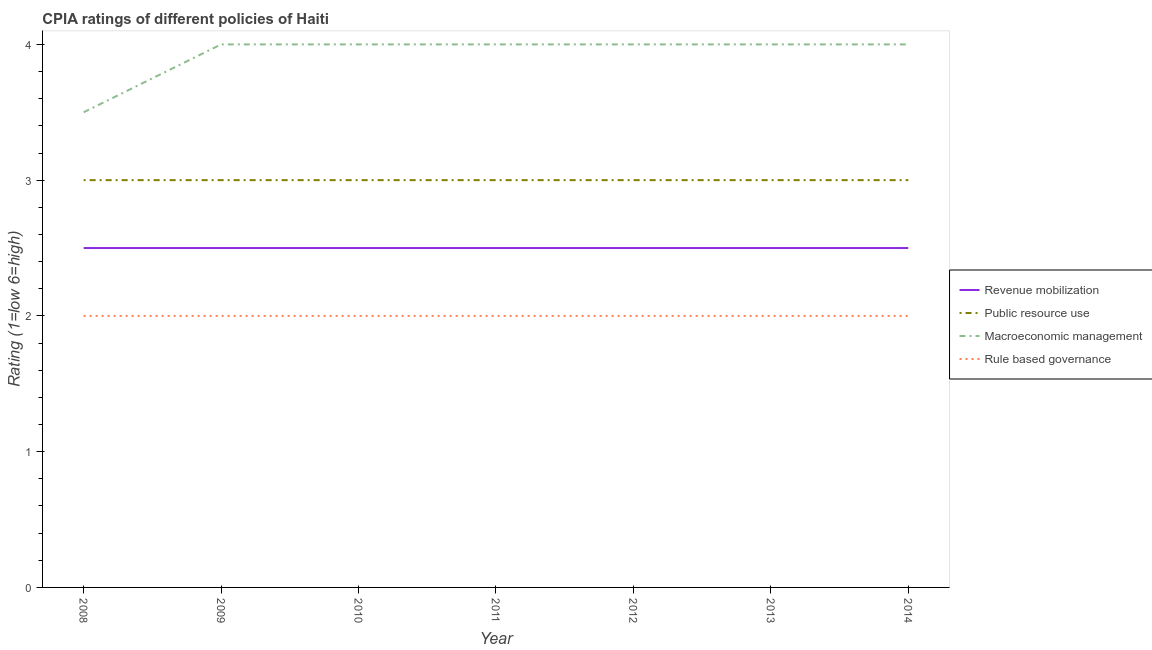How many different coloured lines are there?
Offer a very short reply. 4. Does the line corresponding to cpia rating of public resource use intersect with the line corresponding to cpia rating of rule based governance?
Offer a terse response. No. What is the cpia rating of revenue mobilization in 2011?
Your answer should be compact. 2.5. Across all years, what is the maximum cpia rating of public resource use?
Offer a very short reply. 3. In which year was the cpia rating of rule based governance maximum?
Keep it short and to the point. 2008. What is the total cpia rating of rule based governance in the graph?
Make the answer very short. 14. What is the difference between the cpia rating of revenue mobilization in 2011 and that in 2013?
Provide a short and direct response. 0. What is the average cpia rating of revenue mobilization per year?
Provide a succinct answer. 2.5. In how many years, is the cpia rating of macroeconomic management greater than 2.6?
Offer a very short reply. 7. What is the ratio of the cpia rating of public resource use in 2009 to that in 2014?
Offer a very short reply. 1. Is the cpia rating of macroeconomic management in 2012 less than that in 2013?
Your response must be concise. No. Is the difference between the cpia rating of rule based governance in 2011 and 2012 greater than the difference between the cpia rating of public resource use in 2011 and 2012?
Offer a terse response. No. In how many years, is the cpia rating of macroeconomic management greater than the average cpia rating of macroeconomic management taken over all years?
Offer a very short reply. 6. Is it the case that in every year, the sum of the cpia rating of revenue mobilization and cpia rating of public resource use is greater than the cpia rating of macroeconomic management?
Make the answer very short. Yes. Is the cpia rating of revenue mobilization strictly less than the cpia rating of public resource use over the years?
Provide a short and direct response. Yes. How many lines are there?
Your response must be concise. 4. How many years are there in the graph?
Your answer should be compact. 7. What is the difference between two consecutive major ticks on the Y-axis?
Your answer should be very brief. 1. Are the values on the major ticks of Y-axis written in scientific E-notation?
Keep it short and to the point. No. How many legend labels are there?
Provide a succinct answer. 4. What is the title of the graph?
Provide a short and direct response. CPIA ratings of different policies of Haiti. What is the Rating (1=low 6=high) of Macroeconomic management in 2008?
Offer a terse response. 3.5. What is the Rating (1=low 6=high) in Rule based governance in 2009?
Ensure brevity in your answer.  2. What is the Rating (1=low 6=high) in Revenue mobilization in 2010?
Ensure brevity in your answer.  2.5. What is the Rating (1=low 6=high) in Public resource use in 2010?
Keep it short and to the point. 3. What is the Rating (1=low 6=high) of Revenue mobilization in 2011?
Offer a terse response. 2.5. What is the Rating (1=low 6=high) of Macroeconomic management in 2011?
Keep it short and to the point. 4. What is the Rating (1=low 6=high) of Public resource use in 2012?
Keep it short and to the point. 3. What is the Rating (1=low 6=high) in Macroeconomic management in 2012?
Give a very brief answer. 4. What is the Rating (1=low 6=high) in Rule based governance in 2012?
Provide a short and direct response. 2. What is the Rating (1=low 6=high) in Revenue mobilization in 2013?
Your answer should be very brief. 2.5. What is the Rating (1=low 6=high) in Macroeconomic management in 2014?
Your answer should be compact. 4. Across all years, what is the minimum Rating (1=low 6=high) of Revenue mobilization?
Provide a succinct answer. 2.5. Across all years, what is the minimum Rating (1=low 6=high) of Public resource use?
Offer a terse response. 3. Across all years, what is the minimum Rating (1=low 6=high) in Macroeconomic management?
Make the answer very short. 3.5. What is the total Rating (1=low 6=high) of Revenue mobilization in the graph?
Your answer should be compact. 17.5. What is the total Rating (1=low 6=high) in Public resource use in the graph?
Your response must be concise. 21. What is the difference between the Rating (1=low 6=high) in Revenue mobilization in 2008 and that in 2009?
Ensure brevity in your answer.  0. What is the difference between the Rating (1=low 6=high) of Public resource use in 2008 and that in 2009?
Provide a succinct answer. 0. What is the difference between the Rating (1=low 6=high) in Macroeconomic management in 2008 and that in 2009?
Offer a terse response. -0.5. What is the difference between the Rating (1=low 6=high) in Rule based governance in 2008 and that in 2009?
Offer a very short reply. 0. What is the difference between the Rating (1=low 6=high) of Revenue mobilization in 2008 and that in 2010?
Ensure brevity in your answer.  0. What is the difference between the Rating (1=low 6=high) of Public resource use in 2008 and that in 2010?
Offer a terse response. 0. What is the difference between the Rating (1=low 6=high) in Revenue mobilization in 2008 and that in 2011?
Offer a very short reply. 0. What is the difference between the Rating (1=low 6=high) of Public resource use in 2008 and that in 2011?
Make the answer very short. 0. What is the difference between the Rating (1=low 6=high) in Rule based governance in 2008 and that in 2011?
Offer a very short reply. 0. What is the difference between the Rating (1=low 6=high) of Public resource use in 2008 and that in 2012?
Provide a short and direct response. 0. What is the difference between the Rating (1=low 6=high) of Rule based governance in 2008 and that in 2012?
Provide a succinct answer. 0. What is the difference between the Rating (1=low 6=high) of Rule based governance in 2008 and that in 2013?
Your answer should be compact. 0. What is the difference between the Rating (1=low 6=high) of Revenue mobilization in 2008 and that in 2014?
Your response must be concise. 0. What is the difference between the Rating (1=low 6=high) of Public resource use in 2008 and that in 2014?
Offer a terse response. 0. What is the difference between the Rating (1=low 6=high) of Macroeconomic management in 2008 and that in 2014?
Provide a short and direct response. -0.5. What is the difference between the Rating (1=low 6=high) in Revenue mobilization in 2009 and that in 2010?
Your answer should be compact. 0. What is the difference between the Rating (1=low 6=high) of Macroeconomic management in 2009 and that in 2010?
Keep it short and to the point. 0. What is the difference between the Rating (1=low 6=high) in Rule based governance in 2009 and that in 2010?
Make the answer very short. 0. What is the difference between the Rating (1=low 6=high) of Public resource use in 2009 and that in 2011?
Make the answer very short. 0. What is the difference between the Rating (1=low 6=high) of Macroeconomic management in 2009 and that in 2011?
Ensure brevity in your answer.  0. What is the difference between the Rating (1=low 6=high) in Revenue mobilization in 2009 and that in 2012?
Give a very brief answer. 0. What is the difference between the Rating (1=low 6=high) in Public resource use in 2009 and that in 2012?
Offer a terse response. 0. What is the difference between the Rating (1=low 6=high) of Public resource use in 2009 and that in 2013?
Your answer should be compact. 0. What is the difference between the Rating (1=low 6=high) of Revenue mobilization in 2009 and that in 2014?
Offer a very short reply. 0. What is the difference between the Rating (1=low 6=high) of Public resource use in 2009 and that in 2014?
Your answer should be very brief. 0. What is the difference between the Rating (1=low 6=high) in Rule based governance in 2009 and that in 2014?
Offer a very short reply. 0. What is the difference between the Rating (1=low 6=high) in Revenue mobilization in 2010 and that in 2011?
Your answer should be compact. 0. What is the difference between the Rating (1=low 6=high) of Macroeconomic management in 2010 and that in 2012?
Your answer should be very brief. 0. What is the difference between the Rating (1=low 6=high) in Rule based governance in 2010 and that in 2012?
Ensure brevity in your answer.  0. What is the difference between the Rating (1=low 6=high) in Revenue mobilization in 2010 and that in 2013?
Offer a very short reply. 0. What is the difference between the Rating (1=low 6=high) of Rule based governance in 2010 and that in 2013?
Provide a short and direct response. 0. What is the difference between the Rating (1=low 6=high) of Revenue mobilization in 2010 and that in 2014?
Your response must be concise. 0. What is the difference between the Rating (1=low 6=high) of Macroeconomic management in 2011 and that in 2012?
Provide a succinct answer. 0. What is the difference between the Rating (1=low 6=high) of Macroeconomic management in 2011 and that in 2013?
Offer a terse response. 0. What is the difference between the Rating (1=low 6=high) of Revenue mobilization in 2011 and that in 2014?
Offer a terse response. 0. What is the difference between the Rating (1=low 6=high) of Public resource use in 2011 and that in 2014?
Your answer should be compact. 0. What is the difference between the Rating (1=low 6=high) in Public resource use in 2012 and that in 2013?
Your response must be concise. 0. What is the difference between the Rating (1=low 6=high) of Macroeconomic management in 2012 and that in 2013?
Offer a very short reply. 0. What is the difference between the Rating (1=low 6=high) in Rule based governance in 2012 and that in 2013?
Keep it short and to the point. 0. What is the difference between the Rating (1=low 6=high) in Revenue mobilization in 2012 and that in 2014?
Give a very brief answer. 0. What is the difference between the Rating (1=low 6=high) of Public resource use in 2012 and that in 2014?
Offer a very short reply. 0. What is the difference between the Rating (1=low 6=high) in Macroeconomic management in 2012 and that in 2014?
Your answer should be compact. 0. What is the difference between the Rating (1=low 6=high) of Rule based governance in 2012 and that in 2014?
Ensure brevity in your answer.  0. What is the difference between the Rating (1=low 6=high) of Revenue mobilization in 2013 and that in 2014?
Provide a short and direct response. 0. What is the difference between the Rating (1=low 6=high) in Revenue mobilization in 2008 and the Rating (1=low 6=high) in Public resource use in 2009?
Provide a succinct answer. -0.5. What is the difference between the Rating (1=low 6=high) of Revenue mobilization in 2008 and the Rating (1=low 6=high) of Rule based governance in 2009?
Your answer should be compact. 0.5. What is the difference between the Rating (1=low 6=high) of Revenue mobilization in 2008 and the Rating (1=low 6=high) of Macroeconomic management in 2010?
Your answer should be compact. -1.5. What is the difference between the Rating (1=low 6=high) in Public resource use in 2008 and the Rating (1=low 6=high) in Macroeconomic management in 2010?
Ensure brevity in your answer.  -1. What is the difference between the Rating (1=low 6=high) of Public resource use in 2008 and the Rating (1=low 6=high) of Rule based governance in 2010?
Your response must be concise. 1. What is the difference between the Rating (1=low 6=high) in Revenue mobilization in 2008 and the Rating (1=low 6=high) in Public resource use in 2011?
Your answer should be very brief. -0.5. What is the difference between the Rating (1=low 6=high) of Revenue mobilization in 2008 and the Rating (1=low 6=high) of Macroeconomic management in 2011?
Keep it short and to the point. -1.5. What is the difference between the Rating (1=low 6=high) in Revenue mobilization in 2008 and the Rating (1=low 6=high) in Rule based governance in 2011?
Ensure brevity in your answer.  0.5. What is the difference between the Rating (1=low 6=high) in Public resource use in 2008 and the Rating (1=low 6=high) in Macroeconomic management in 2011?
Provide a short and direct response. -1. What is the difference between the Rating (1=low 6=high) of Macroeconomic management in 2008 and the Rating (1=low 6=high) of Rule based governance in 2011?
Ensure brevity in your answer.  1.5. What is the difference between the Rating (1=low 6=high) of Revenue mobilization in 2008 and the Rating (1=low 6=high) of Public resource use in 2012?
Make the answer very short. -0.5. What is the difference between the Rating (1=low 6=high) in Revenue mobilization in 2008 and the Rating (1=low 6=high) in Rule based governance in 2012?
Provide a succinct answer. 0.5. What is the difference between the Rating (1=low 6=high) of Public resource use in 2008 and the Rating (1=low 6=high) of Macroeconomic management in 2012?
Your answer should be compact. -1. What is the difference between the Rating (1=low 6=high) of Public resource use in 2008 and the Rating (1=low 6=high) of Rule based governance in 2012?
Offer a terse response. 1. What is the difference between the Rating (1=low 6=high) in Revenue mobilization in 2008 and the Rating (1=low 6=high) in Rule based governance in 2013?
Provide a short and direct response. 0.5. What is the difference between the Rating (1=low 6=high) in Revenue mobilization in 2008 and the Rating (1=low 6=high) in Macroeconomic management in 2014?
Keep it short and to the point. -1.5. What is the difference between the Rating (1=low 6=high) in Public resource use in 2008 and the Rating (1=low 6=high) in Rule based governance in 2014?
Keep it short and to the point. 1. What is the difference between the Rating (1=low 6=high) of Macroeconomic management in 2008 and the Rating (1=low 6=high) of Rule based governance in 2014?
Your answer should be very brief. 1.5. What is the difference between the Rating (1=low 6=high) of Revenue mobilization in 2009 and the Rating (1=low 6=high) of Macroeconomic management in 2010?
Keep it short and to the point. -1.5. What is the difference between the Rating (1=low 6=high) in Macroeconomic management in 2009 and the Rating (1=low 6=high) in Rule based governance in 2010?
Provide a short and direct response. 2. What is the difference between the Rating (1=low 6=high) of Revenue mobilization in 2009 and the Rating (1=low 6=high) of Public resource use in 2011?
Offer a very short reply. -0.5. What is the difference between the Rating (1=low 6=high) of Revenue mobilization in 2009 and the Rating (1=low 6=high) of Macroeconomic management in 2011?
Provide a succinct answer. -1.5. What is the difference between the Rating (1=low 6=high) in Revenue mobilization in 2009 and the Rating (1=low 6=high) in Rule based governance in 2011?
Make the answer very short. 0.5. What is the difference between the Rating (1=low 6=high) of Public resource use in 2009 and the Rating (1=low 6=high) of Macroeconomic management in 2011?
Your answer should be very brief. -1. What is the difference between the Rating (1=low 6=high) of Public resource use in 2009 and the Rating (1=low 6=high) of Rule based governance in 2011?
Your answer should be very brief. 1. What is the difference between the Rating (1=low 6=high) in Revenue mobilization in 2009 and the Rating (1=low 6=high) in Macroeconomic management in 2012?
Give a very brief answer. -1.5. What is the difference between the Rating (1=low 6=high) in Public resource use in 2009 and the Rating (1=low 6=high) in Macroeconomic management in 2012?
Make the answer very short. -1. What is the difference between the Rating (1=low 6=high) of Revenue mobilization in 2009 and the Rating (1=low 6=high) of Public resource use in 2013?
Provide a short and direct response. -0.5. What is the difference between the Rating (1=low 6=high) of Public resource use in 2009 and the Rating (1=low 6=high) of Macroeconomic management in 2013?
Keep it short and to the point. -1. What is the difference between the Rating (1=low 6=high) in Public resource use in 2009 and the Rating (1=low 6=high) in Rule based governance in 2013?
Offer a terse response. 1. What is the difference between the Rating (1=low 6=high) in Revenue mobilization in 2009 and the Rating (1=low 6=high) in Public resource use in 2014?
Ensure brevity in your answer.  -0.5. What is the difference between the Rating (1=low 6=high) in Revenue mobilization in 2009 and the Rating (1=low 6=high) in Rule based governance in 2014?
Provide a succinct answer. 0.5. What is the difference between the Rating (1=low 6=high) in Public resource use in 2010 and the Rating (1=low 6=high) in Rule based governance in 2011?
Make the answer very short. 1. What is the difference between the Rating (1=low 6=high) of Macroeconomic management in 2010 and the Rating (1=low 6=high) of Rule based governance in 2011?
Offer a very short reply. 2. What is the difference between the Rating (1=low 6=high) in Revenue mobilization in 2010 and the Rating (1=low 6=high) in Public resource use in 2012?
Make the answer very short. -0.5. What is the difference between the Rating (1=low 6=high) in Revenue mobilization in 2010 and the Rating (1=low 6=high) in Macroeconomic management in 2012?
Your response must be concise. -1.5. What is the difference between the Rating (1=low 6=high) of Revenue mobilization in 2010 and the Rating (1=low 6=high) of Rule based governance in 2012?
Keep it short and to the point. 0.5. What is the difference between the Rating (1=low 6=high) of Public resource use in 2010 and the Rating (1=low 6=high) of Macroeconomic management in 2012?
Make the answer very short. -1. What is the difference between the Rating (1=low 6=high) in Public resource use in 2010 and the Rating (1=low 6=high) in Rule based governance in 2012?
Keep it short and to the point. 1. What is the difference between the Rating (1=low 6=high) of Macroeconomic management in 2010 and the Rating (1=low 6=high) of Rule based governance in 2012?
Your answer should be very brief. 2. What is the difference between the Rating (1=low 6=high) of Revenue mobilization in 2010 and the Rating (1=low 6=high) of Public resource use in 2013?
Provide a short and direct response. -0.5. What is the difference between the Rating (1=low 6=high) in Revenue mobilization in 2010 and the Rating (1=low 6=high) in Macroeconomic management in 2013?
Make the answer very short. -1.5. What is the difference between the Rating (1=low 6=high) of Revenue mobilization in 2010 and the Rating (1=low 6=high) of Rule based governance in 2013?
Offer a terse response. 0.5. What is the difference between the Rating (1=low 6=high) of Public resource use in 2010 and the Rating (1=low 6=high) of Rule based governance in 2013?
Keep it short and to the point. 1. What is the difference between the Rating (1=low 6=high) of Macroeconomic management in 2010 and the Rating (1=low 6=high) of Rule based governance in 2013?
Your answer should be compact. 2. What is the difference between the Rating (1=low 6=high) of Revenue mobilization in 2010 and the Rating (1=low 6=high) of Macroeconomic management in 2014?
Ensure brevity in your answer.  -1.5. What is the difference between the Rating (1=low 6=high) of Revenue mobilization in 2010 and the Rating (1=low 6=high) of Rule based governance in 2014?
Provide a short and direct response. 0.5. What is the difference between the Rating (1=low 6=high) of Macroeconomic management in 2010 and the Rating (1=low 6=high) of Rule based governance in 2014?
Offer a very short reply. 2. What is the difference between the Rating (1=low 6=high) of Revenue mobilization in 2011 and the Rating (1=low 6=high) of Public resource use in 2012?
Ensure brevity in your answer.  -0.5. What is the difference between the Rating (1=low 6=high) in Revenue mobilization in 2011 and the Rating (1=low 6=high) in Rule based governance in 2012?
Offer a terse response. 0.5. What is the difference between the Rating (1=low 6=high) of Public resource use in 2011 and the Rating (1=low 6=high) of Macroeconomic management in 2012?
Offer a very short reply. -1. What is the difference between the Rating (1=low 6=high) of Public resource use in 2011 and the Rating (1=low 6=high) of Macroeconomic management in 2013?
Your answer should be compact. -1. What is the difference between the Rating (1=low 6=high) of Macroeconomic management in 2011 and the Rating (1=low 6=high) of Rule based governance in 2013?
Keep it short and to the point. 2. What is the difference between the Rating (1=low 6=high) of Revenue mobilization in 2011 and the Rating (1=low 6=high) of Public resource use in 2014?
Keep it short and to the point. -0.5. What is the difference between the Rating (1=low 6=high) of Revenue mobilization in 2011 and the Rating (1=low 6=high) of Macroeconomic management in 2014?
Ensure brevity in your answer.  -1.5. What is the difference between the Rating (1=low 6=high) in Public resource use in 2012 and the Rating (1=low 6=high) in Macroeconomic management in 2013?
Provide a succinct answer. -1. What is the difference between the Rating (1=low 6=high) in Public resource use in 2012 and the Rating (1=low 6=high) in Rule based governance in 2013?
Provide a short and direct response. 1. What is the difference between the Rating (1=low 6=high) in Macroeconomic management in 2012 and the Rating (1=low 6=high) in Rule based governance in 2013?
Your answer should be very brief. 2. What is the difference between the Rating (1=low 6=high) in Public resource use in 2012 and the Rating (1=low 6=high) in Rule based governance in 2014?
Offer a very short reply. 1. What is the difference between the Rating (1=low 6=high) in Revenue mobilization in 2013 and the Rating (1=low 6=high) in Macroeconomic management in 2014?
Offer a terse response. -1.5. What is the difference between the Rating (1=low 6=high) in Public resource use in 2013 and the Rating (1=low 6=high) in Rule based governance in 2014?
Your answer should be very brief. 1. What is the average Rating (1=low 6=high) in Public resource use per year?
Offer a very short reply. 3. What is the average Rating (1=low 6=high) of Macroeconomic management per year?
Your answer should be compact. 3.93. In the year 2008, what is the difference between the Rating (1=low 6=high) in Revenue mobilization and Rating (1=low 6=high) in Macroeconomic management?
Offer a very short reply. -1. In the year 2008, what is the difference between the Rating (1=low 6=high) of Revenue mobilization and Rating (1=low 6=high) of Rule based governance?
Your answer should be very brief. 0.5. In the year 2008, what is the difference between the Rating (1=low 6=high) in Public resource use and Rating (1=low 6=high) in Macroeconomic management?
Offer a very short reply. -0.5. In the year 2008, what is the difference between the Rating (1=low 6=high) in Public resource use and Rating (1=low 6=high) in Rule based governance?
Provide a short and direct response. 1. In the year 2008, what is the difference between the Rating (1=low 6=high) of Macroeconomic management and Rating (1=low 6=high) of Rule based governance?
Provide a succinct answer. 1.5. In the year 2009, what is the difference between the Rating (1=low 6=high) of Revenue mobilization and Rating (1=low 6=high) of Public resource use?
Your answer should be compact. -0.5. In the year 2010, what is the difference between the Rating (1=low 6=high) in Revenue mobilization and Rating (1=low 6=high) in Public resource use?
Keep it short and to the point. -0.5. In the year 2010, what is the difference between the Rating (1=low 6=high) in Revenue mobilization and Rating (1=low 6=high) in Macroeconomic management?
Your response must be concise. -1.5. In the year 2010, what is the difference between the Rating (1=low 6=high) of Public resource use and Rating (1=low 6=high) of Macroeconomic management?
Your answer should be very brief. -1. In the year 2011, what is the difference between the Rating (1=low 6=high) of Revenue mobilization and Rating (1=low 6=high) of Public resource use?
Make the answer very short. -0.5. In the year 2011, what is the difference between the Rating (1=low 6=high) of Revenue mobilization and Rating (1=low 6=high) of Macroeconomic management?
Make the answer very short. -1.5. In the year 2011, what is the difference between the Rating (1=low 6=high) in Revenue mobilization and Rating (1=low 6=high) in Rule based governance?
Make the answer very short. 0.5. In the year 2011, what is the difference between the Rating (1=low 6=high) in Public resource use and Rating (1=low 6=high) in Macroeconomic management?
Give a very brief answer. -1. In the year 2011, what is the difference between the Rating (1=low 6=high) of Macroeconomic management and Rating (1=low 6=high) of Rule based governance?
Offer a very short reply. 2. In the year 2012, what is the difference between the Rating (1=low 6=high) in Revenue mobilization and Rating (1=low 6=high) in Public resource use?
Give a very brief answer. -0.5. In the year 2012, what is the difference between the Rating (1=low 6=high) of Public resource use and Rating (1=low 6=high) of Macroeconomic management?
Keep it short and to the point. -1. In the year 2012, what is the difference between the Rating (1=low 6=high) in Macroeconomic management and Rating (1=low 6=high) in Rule based governance?
Your response must be concise. 2. In the year 2013, what is the difference between the Rating (1=low 6=high) of Revenue mobilization and Rating (1=low 6=high) of Public resource use?
Make the answer very short. -0.5. In the year 2013, what is the difference between the Rating (1=low 6=high) in Public resource use and Rating (1=low 6=high) in Rule based governance?
Give a very brief answer. 1. In the year 2013, what is the difference between the Rating (1=low 6=high) in Macroeconomic management and Rating (1=low 6=high) in Rule based governance?
Keep it short and to the point. 2. In the year 2014, what is the difference between the Rating (1=low 6=high) in Revenue mobilization and Rating (1=low 6=high) in Public resource use?
Your answer should be compact. -0.5. In the year 2014, what is the difference between the Rating (1=low 6=high) of Revenue mobilization and Rating (1=low 6=high) of Macroeconomic management?
Offer a terse response. -1.5. In the year 2014, what is the difference between the Rating (1=low 6=high) in Public resource use and Rating (1=low 6=high) in Macroeconomic management?
Your answer should be very brief. -1. What is the ratio of the Rating (1=low 6=high) in Public resource use in 2008 to that in 2009?
Offer a terse response. 1. What is the ratio of the Rating (1=low 6=high) in Public resource use in 2008 to that in 2010?
Keep it short and to the point. 1. What is the ratio of the Rating (1=low 6=high) of Macroeconomic management in 2008 to that in 2010?
Your answer should be very brief. 0.88. What is the ratio of the Rating (1=low 6=high) in Public resource use in 2008 to that in 2011?
Provide a short and direct response. 1. What is the ratio of the Rating (1=low 6=high) of Public resource use in 2008 to that in 2012?
Offer a terse response. 1. What is the ratio of the Rating (1=low 6=high) in Macroeconomic management in 2008 to that in 2012?
Provide a short and direct response. 0.88. What is the ratio of the Rating (1=low 6=high) of Rule based governance in 2008 to that in 2012?
Give a very brief answer. 1. What is the ratio of the Rating (1=low 6=high) in Revenue mobilization in 2008 to that in 2013?
Give a very brief answer. 1. What is the ratio of the Rating (1=low 6=high) of Macroeconomic management in 2008 to that in 2013?
Your response must be concise. 0.88. What is the ratio of the Rating (1=low 6=high) in Public resource use in 2008 to that in 2014?
Your answer should be very brief. 1. What is the ratio of the Rating (1=low 6=high) of Rule based governance in 2008 to that in 2014?
Your response must be concise. 1. What is the ratio of the Rating (1=low 6=high) in Macroeconomic management in 2009 to that in 2010?
Keep it short and to the point. 1. What is the ratio of the Rating (1=low 6=high) in Rule based governance in 2009 to that in 2010?
Offer a terse response. 1. What is the ratio of the Rating (1=low 6=high) in Macroeconomic management in 2009 to that in 2011?
Provide a short and direct response. 1. What is the ratio of the Rating (1=low 6=high) of Rule based governance in 2009 to that in 2011?
Your answer should be very brief. 1. What is the ratio of the Rating (1=low 6=high) in Macroeconomic management in 2009 to that in 2013?
Give a very brief answer. 1. What is the ratio of the Rating (1=low 6=high) in Revenue mobilization in 2009 to that in 2014?
Your response must be concise. 1. What is the ratio of the Rating (1=low 6=high) in Public resource use in 2009 to that in 2014?
Offer a very short reply. 1. What is the ratio of the Rating (1=low 6=high) of Rule based governance in 2009 to that in 2014?
Your response must be concise. 1. What is the ratio of the Rating (1=low 6=high) of Revenue mobilization in 2010 to that in 2011?
Your response must be concise. 1. What is the ratio of the Rating (1=low 6=high) in Public resource use in 2010 to that in 2011?
Provide a short and direct response. 1. What is the ratio of the Rating (1=low 6=high) of Macroeconomic management in 2010 to that in 2012?
Your answer should be compact. 1. What is the ratio of the Rating (1=low 6=high) of Macroeconomic management in 2010 to that in 2013?
Offer a very short reply. 1. What is the ratio of the Rating (1=low 6=high) of Rule based governance in 2010 to that in 2014?
Your answer should be very brief. 1. What is the ratio of the Rating (1=low 6=high) of Revenue mobilization in 2011 to that in 2012?
Offer a terse response. 1. What is the ratio of the Rating (1=low 6=high) in Rule based governance in 2011 to that in 2012?
Provide a short and direct response. 1. What is the ratio of the Rating (1=low 6=high) of Revenue mobilization in 2011 to that in 2014?
Provide a short and direct response. 1. What is the ratio of the Rating (1=low 6=high) in Macroeconomic management in 2011 to that in 2014?
Keep it short and to the point. 1. What is the ratio of the Rating (1=low 6=high) in Rule based governance in 2011 to that in 2014?
Your answer should be compact. 1. What is the ratio of the Rating (1=low 6=high) in Public resource use in 2012 to that in 2013?
Your response must be concise. 1. What is the ratio of the Rating (1=low 6=high) of Revenue mobilization in 2012 to that in 2014?
Your answer should be very brief. 1. What is the ratio of the Rating (1=low 6=high) of Macroeconomic management in 2012 to that in 2014?
Ensure brevity in your answer.  1. What is the ratio of the Rating (1=low 6=high) in Rule based governance in 2012 to that in 2014?
Ensure brevity in your answer.  1. What is the ratio of the Rating (1=low 6=high) of Rule based governance in 2013 to that in 2014?
Give a very brief answer. 1. What is the difference between the highest and the second highest Rating (1=low 6=high) in Public resource use?
Make the answer very short. 0. What is the difference between the highest and the lowest Rating (1=low 6=high) in Public resource use?
Make the answer very short. 0. What is the difference between the highest and the lowest Rating (1=low 6=high) of Macroeconomic management?
Offer a very short reply. 0.5. 